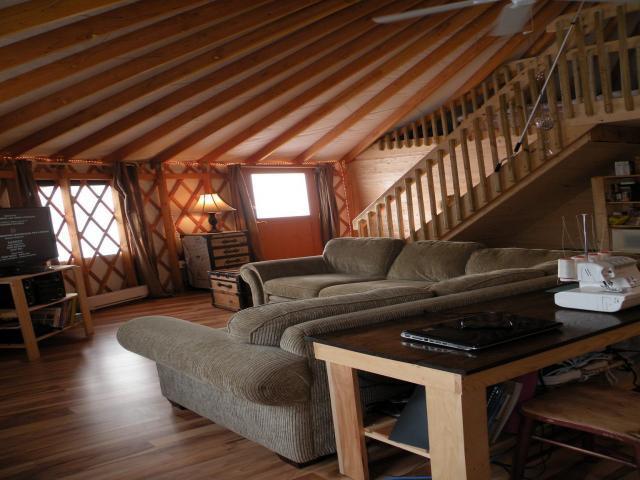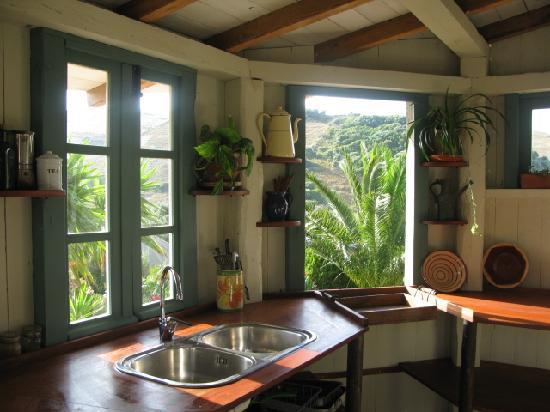The first image is the image on the left, the second image is the image on the right. Analyze the images presented: Is the assertion "One image shows the kitchen of a yurt with white refrigerator and microwave, near a dining seating area with wooden kitchen chairs." valid? Answer yes or no. No. The first image is the image on the left, the second image is the image on the right. For the images displayed, is the sentence "An image shows a sky-light type many-sided element at the peak of a room's ceiling." factually correct? Answer yes or no. No. 